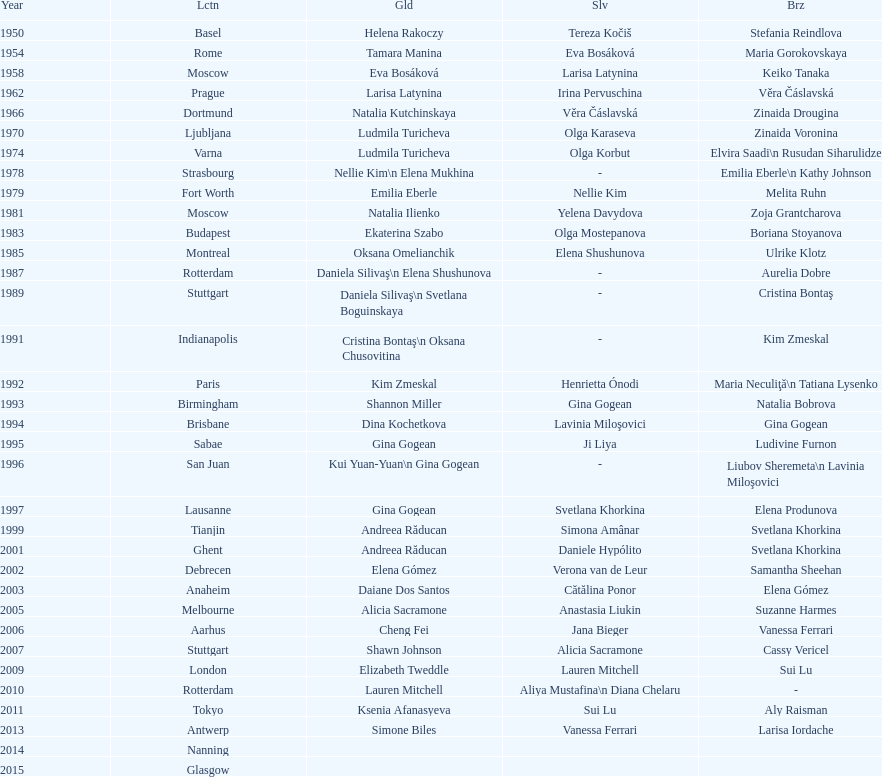How long is the time between the times the championship was held in moscow? 23 years. 